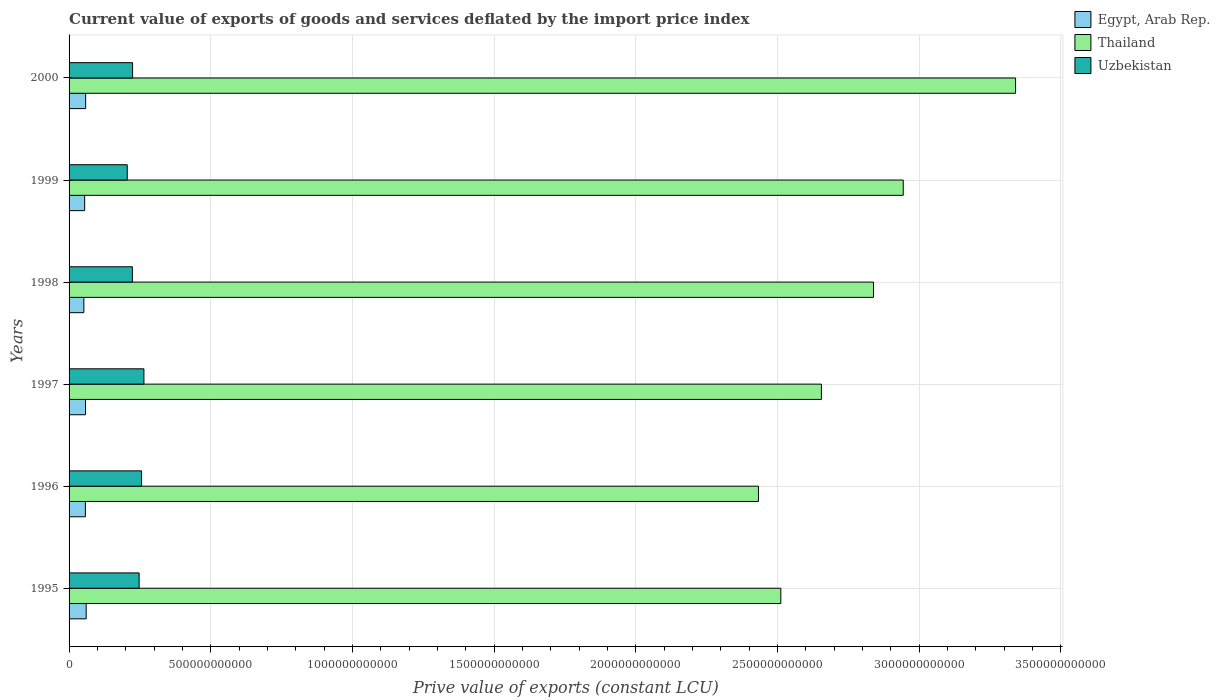How many different coloured bars are there?
Provide a short and direct response. 3. Are the number of bars per tick equal to the number of legend labels?
Keep it short and to the point. Yes. What is the prive value of exports in Uzbekistan in 2000?
Offer a terse response. 2.24e+11. Across all years, what is the maximum prive value of exports in Uzbekistan?
Give a very brief answer. 2.64e+11. Across all years, what is the minimum prive value of exports in Egypt, Arab Rep.?
Give a very brief answer. 5.22e+1. In which year was the prive value of exports in Egypt, Arab Rep. maximum?
Make the answer very short. 1995. In which year was the prive value of exports in Uzbekistan minimum?
Keep it short and to the point. 1999. What is the total prive value of exports in Uzbekistan in the graph?
Offer a very short reply. 1.42e+12. What is the difference between the prive value of exports in Thailand in 1998 and that in 1999?
Your response must be concise. -1.05e+11. What is the difference between the prive value of exports in Uzbekistan in 1996 and the prive value of exports in Thailand in 1997?
Give a very brief answer. -2.40e+12. What is the average prive value of exports in Egypt, Arab Rep. per year?
Ensure brevity in your answer.  5.70e+1. In the year 1999, what is the difference between the prive value of exports in Egypt, Arab Rep. and prive value of exports in Thailand?
Provide a succinct answer. -2.89e+12. What is the ratio of the prive value of exports in Thailand in 1997 to that in 1999?
Give a very brief answer. 0.9. Is the prive value of exports in Egypt, Arab Rep. in 1999 less than that in 2000?
Provide a succinct answer. Yes. What is the difference between the highest and the second highest prive value of exports in Thailand?
Ensure brevity in your answer.  3.96e+11. What is the difference between the highest and the lowest prive value of exports in Egypt, Arab Rep.?
Offer a very short reply. 8.20e+09. What does the 3rd bar from the top in 1999 represents?
Provide a succinct answer. Egypt, Arab Rep. What does the 1st bar from the bottom in 1998 represents?
Offer a terse response. Egypt, Arab Rep. Are all the bars in the graph horizontal?
Offer a terse response. Yes. How many years are there in the graph?
Offer a very short reply. 6. What is the difference between two consecutive major ticks on the X-axis?
Give a very brief answer. 5.00e+11. Are the values on the major ticks of X-axis written in scientific E-notation?
Keep it short and to the point. No. Does the graph contain any zero values?
Your answer should be very brief. No. Does the graph contain grids?
Your answer should be very brief. Yes. Where does the legend appear in the graph?
Your response must be concise. Top right. How many legend labels are there?
Provide a succinct answer. 3. How are the legend labels stacked?
Your response must be concise. Vertical. What is the title of the graph?
Give a very brief answer. Current value of exports of goods and services deflated by the import price index. Does "South Sudan" appear as one of the legend labels in the graph?
Provide a succinct answer. No. What is the label or title of the X-axis?
Your answer should be compact. Prive value of exports (constant LCU). What is the Prive value of exports (constant LCU) in Egypt, Arab Rep. in 1995?
Your answer should be very brief. 6.04e+1. What is the Prive value of exports (constant LCU) in Thailand in 1995?
Keep it short and to the point. 2.51e+12. What is the Prive value of exports (constant LCU) in Uzbekistan in 1995?
Offer a very short reply. 2.47e+11. What is the Prive value of exports (constant LCU) of Egypt, Arab Rep. in 1996?
Keep it short and to the point. 5.76e+1. What is the Prive value of exports (constant LCU) of Thailand in 1996?
Give a very brief answer. 2.43e+12. What is the Prive value of exports (constant LCU) of Uzbekistan in 1996?
Offer a terse response. 2.56e+11. What is the Prive value of exports (constant LCU) of Egypt, Arab Rep. in 1997?
Provide a short and direct response. 5.80e+1. What is the Prive value of exports (constant LCU) of Thailand in 1997?
Your response must be concise. 2.65e+12. What is the Prive value of exports (constant LCU) of Uzbekistan in 1997?
Your response must be concise. 2.64e+11. What is the Prive value of exports (constant LCU) of Egypt, Arab Rep. in 1998?
Your response must be concise. 5.22e+1. What is the Prive value of exports (constant LCU) in Thailand in 1998?
Ensure brevity in your answer.  2.84e+12. What is the Prive value of exports (constant LCU) of Uzbekistan in 1998?
Give a very brief answer. 2.23e+11. What is the Prive value of exports (constant LCU) of Egypt, Arab Rep. in 1999?
Your answer should be very brief. 5.50e+1. What is the Prive value of exports (constant LCU) in Thailand in 1999?
Your response must be concise. 2.94e+12. What is the Prive value of exports (constant LCU) in Uzbekistan in 1999?
Make the answer very short. 2.05e+11. What is the Prive value of exports (constant LCU) in Egypt, Arab Rep. in 2000?
Give a very brief answer. 5.85e+1. What is the Prive value of exports (constant LCU) in Thailand in 2000?
Provide a short and direct response. 3.34e+12. What is the Prive value of exports (constant LCU) in Uzbekistan in 2000?
Your answer should be very brief. 2.24e+11. Across all years, what is the maximum Prive value of exports (constant LCU) of Egypt, Arab Rep.?
Your answer should be very brief. 6.04e+1. Across all years, what is the maximum Prive value of exports (constant LCU) in Thailand?
Offer a very short reply. 3.34e+12. Across all years, what is the maximum Prive value of exports (constant LCU) of Uzbekistan?
Your answer should be compact. 2.64e+11. Across all years, what is the minimum Prive value of exports (constant LCU) of Egypt, Arab Rep.?
Make the answer very short. 5.22e+1. Across all years, what is the minimum Prive value of exports (constant LCU) in Thailand?
Keep it short and to the point. 2.43e+12. Across all years, what is the minimum Prive value of exports (constant LCU) in Uzbekistan?
Your answer should be very brief. 2.05e+11. What is the total Prive value of exports (constant LCU) in Egypt, Arab Rep. in the graph?
Make the answer very short. 3.42e+11. What is the total Prive value of exports (constant LCU) of Thailand in the graph?
Ensure brevity in your answer.  1.67e+13. What is the total Prive value of exports (constant LCU) of Uzbekistan in the graph?
Your answer should be very brief. 1.42e+12. What is the difference between the Prive value of exports (constant LCU) in Egypt, Arab Rep. in 1995 and that in 1996?
Ensure brevity in your answer.  2.79e+09. What is the difference between the Prive value of exports (constant LCU) in Thailand in 1995 and that in 1996?
Provide a succinct answer. 7.90e+1. What is the difference between the Prive value of exports (constant LCU) in Uzbekistan in 1995 and that in 1996?
Your answer should be compact. -8.68e+09. What is the difference between the Prive value of exports (constant LCU) of Egypt, Arab Rep. in 1995 and that in 1997?
Offer a terse response. 2.39e+09. What is the difference between the Prive value of exports (constant LCU) in Thailand in 1995 and that in 1997?
Ensure brevity in your answer.  -1.43e+11. What is the difference between the Prive value of exports (constant LCU) in Uzbekistan in 1995 and that in 1997?
Provide a succinct answer. -1.70e+1. What is the difference between the Prive value of exports (constant LCU) of Egypt, Arab Rep. in 1995 and that in 1998?
Offer a very short reply. 8.20e+09. What is the difference between the Prive value of exports (constant LCU) of Thailand in 1995 and that in 1998?
Provide a short and direct response. -3.27e+11. What is the difference between the Prive value of exports (constant LCU) of Uzbekistan in 1995 and that in 1998?
Offer a very short reply. 2.38e+1. What is the difference between the Prive value of exports (constant LCU) of Egypt, Arab Rep. in 1995 and that in 1999?
Offer a very short reply. 5.37e+09. What is the difference between the Prive value of exports (constant LCU) of Thailand in 1995 and that in 1999?
Offer a terse response. -4.32e+11. What is the difference between the Prive value of exports (constant LCU) in Uzbekistan in 1995 and that in 1999?
Ensure brevity in your answer.  4.19e+1. What is the difference between the Prive value of exports (constant LCU) of Egypt, Arab Rep. in 1995 and that in 2000?
Offer a very short reply. 1.95e+09. What is the difference between the Prive value of exports (constant LCU) in Thailand in 1995 and that in 2000?
Your answer should be very brief. -8.28e+11. What is the difference between the Prive value of exports (constant LCU) of Uzbekistan in 1995 and that in 2000?
Your answer should be very brief. 2.30e+1. What is the difference between the Prive value of exports (constant LCU) of Egypt, Arab Rep. in 1996 and that in 1997?
Keep it short and to the point. -3.99e+08. What is the difference between the Prive value of exports (constant LCU) in Thailand in 1996 and that in 1997?
Your answer should be very brief. -2.22e+11. What is the difference between the Prive value of exports (constant LCU) in Uzbekistan in 1996 and that in 1997?
Provide a succinct answer. -8.28e+09. What is the difference between the Prive value of exports (constant LCU) in Egypt, Arab Rep. in 1996 and that in 1998?
Provide a succinct answer. 5.41e+09. What is the difference between the Prive value of exports (constant LCU) in Thailand in 1996 and that in 1998?
Give a very brief answer. -4.06e+11. What is the difference between the Prive value of exports (constant LCU) of Uzbekistan in 1996 and that in 1998?
Your response must be concise. 3.25e+1. What is the difference between the Prive value of exports (constant LCU) in Egypt, Arab Rep. in 1996 and that in 1999?
Provide a succinct answer. 2.58e+09. What is the difference between the Prive value of exports (constant LCU) of Thailand in 1996 and that in 1999?
Your answer should be compact. -5.11e+11. What is the difference between the Prive value of exports (constant LCU) in Uzbekistan in 1996 and that in 1999?
Offer a very short reply. 5.06e+1. What is the difference between the Prive value of exports (constant LCU) of Egypt, Arab Rep. in 1996 and that in 2000?
Your answer should be compact. -8.45e+08. What is the difference between the Prive value of exports (constant LCU) in Thailand in 1996 and that in 2000?
Provide a short and direct response. -9.07e+11. What is the difference between the Prive value of exports (constant LCU) in Uzbekistan in 1996 and that in 2000?
Provide a succinct answer. 3.17e+1. What is the difference between the Prive value of exports (constant LCU) in Egypt, Arab Rep. in 1997 and that in 1998?
Make the answer very short. 5.81e+09. What is the difference between the Prive value of exports (constant LCU) in Thailand in 1997 and that in 1998?
Provide a succinct answer. -1.84e+11. What is the difference between the Prive value of exports (constant LCU) in Uzbekistan in 1997 and that in 1998?
Keep it short and to the point. 4.07e+1. What is the difference between the Prive value of exports (constant LCU) of Egypt, Arab Rep. in 1997 and that in 1999?
Make the answer very short. 2.98e+09. What is the difference between the Prive value of exports (constant LCU) of Thailand in 1997 and that in 1999?
Offer a very short reply. -2.89e+11. What is the difference between the Prive value of exports (constant LCU) in Uzbekistan in 1997 and that in 1999?
Offer a terse response. 5.88e+1. What is the difference between the Prive value of exports (constant LCU) of Egypt, Arab Rep. in 1997 and that in 2000?
Keep it short and to the point. -4.45e+08. What is the difference between the Prive value of exports (constant LCU) in Thailand in 1997 and that in 2000?
Give a very brief answer. -6.85e+11. What is the difference between the Prive value of exports (constant LCU) in Uzbekistan in 1997 and that in 2000?
Keep it short and to the point. 4.00e+1. What is the difference between the Prive value of exports (constant LCU) of Egypt, Arab Rep. in 1998 and that in 1999?
Ensure brevity in your answer.  -2.83e+09. What is the difference between the Prive value of exports (constant LCU) of Thailand in 1998 and that in 1999?
Your answer should be compact. -1.05e+11. What is the difference between the Prive value of exports (constant LCU) in Uzbekistan in 1998 and that in 1999?
Keep it short and to the point. 1.81e+1. What is the difference between the Prive value of exports (constant LCU) in Egypt, Arab Rep. in 1998 and that in 2000?
Give a very brief answer. -6.25e+09. What is the difference between the Prive value of exports (constant LCU) in Thailand in 1998 and that in 2000?
Ensure brevity in your answer.  -5.01e+11. What is the difference between the Prive value of exports (constant LCU) of Uzbekistan in 1998 and that in 2000?
Offer a very short reply. -7.55e+08. What is the difference between the Prive value of exports (constant LCU) of Egypt, Arab Rep. in 1999 and that in 2000?
Your answer should be compact. -3.42e+09. What is the difference between the Prive value of exports (constant LCU) of Thailand in 1999 and that in 2000?
Ensure brevity in your answer.  -3.96e+11. What is the difference between the Prive value of exports (constant LCU) of Uzbekistan in 1999 and that in 2000?
Provide a short and direct response. -1.88e+1. What is the difference between the Prive value of exports (constant LCU) in Egypt, Arab Rep. in 1995 and the Prive value of exports (constant LCU) in Thailand in 1996?
Make the answer very short. -2.37e+12. What is the difference between the Prive value of exports (constant LCU) in Egypt, Arab Rep. in 1995 and the Prive value of exports (constant LCU) in Uzbekistan in 1996?
Make the answer very short. -1.95e+11. What is the difference between the Prive value of exports (constant LCU) in Thailand in 1995 and the Prive value of exports (constant LCU) in Uzbekistan in 1996?
Provide a short and direct response. 2.26e+12. What is the difference between the Prive value of exports (constant LCU) of Egypt, Arab Rep. in 1995 and the Prive value of exports (constant LCU) of Thailand in 1997?
Ensure brevity in your answer.  -2.59e+12. What is the difference between the Prive value of exports (constant LCU) of Egypt, Arab Rep. in 1995 and the Prive value of exports (constant LCU) of Uzbekistan in 1997?
Offer a terse response. -2.04e+11. What is the difference between the Prive value of exports (constant LCU) of Thailand in 1995 and the Prive value of exports (constant LCU) of Uzbekistan in 1997?
Your answer should be very brief. 2.25e+12. What is the difference between the Prive value of exports (constant LCU) in Egypt, Arab Rep. in 1995 and the Prive value of exports (constant LCU) in Thailand in 1998?
Offer a very short reply. -2.78e+12. What is the difference between the Prive value of exports (constant LCU) in Egypt, Arab Rep. in 1995 and the Prive value of exports (constant LCU) in Uzbekistan in 1998?
Keep it short and to the point. -1.63e+11. What is the difference between the Prive value of exports (constant LCU) in Thailand in 1995 and the Prive value of exports (constant LCU) in Uzbekistan in 1998?
Ensure brevity in your answer.  2.29e+12. What is the difference between the Prive value of exports (constant LCU) in Egypt, Arab Rep. in 1995 and the Prive value of exports (constant LCU) in Thailand in 1999?
Offer a terse response. -2.88e+12. What is the difference between the Prive value of exports (constant LCU) in Egypt, Arab Rep. in 1995 and the Prive value of exports (constant LCU) in Uzbekistan in 1999?
Your answer should be compact. -1.45e+11. What is the difference between the Prive value of exports (constant LCU) of Thailand in 1995 and the Prive value of exports (constant LCU) of Uzbekistan in 1999?
Provide a succinct answer. 2.31e+12. What is the difference between the Prive value of exports (constant LCU) in Egypt, Arab Rep. in 1995 and the Prive value of exports (constant LCU) in Thailand in 2000?
Offer a very short reply. -3.28e+12. What is the difference between the Prive value of exports (constant LCU) of Egypt, Arab Rep. in 1995 and the Prive value of exports (constant LCU) of Uzbekistan in 2000?
Make the answer very short. -1.64e+11. What is the difference between the Prive value of exports (constant LCU) of Thailand in 1995 and the Prive value of exports (constant LCU) of Uzbekistan in 2000?
Offer a terse response. 2.29e+12. What is the difference between the Prive value of exports (constant LCU) of Egypt, Arab Rep. in 1996 and the Prive value of exports (constant LCU) of Thailand in 1997?
Offer a very short reply. -2.60e+12. What is the difference between the Prive value of exports (constant LCU) in Egypt, Arab Rep. in 1996 and the Prive value of exports (constant LCU) in Uzbekistan in 1997?
Your answer should be very brief. -2.07e+11. What is the difference between the Prive value of exports (constant LCU) of Thailand in 1996 and the Prive value of exports (constant LCU) of Uzbekistan in 1997?
Keep it short and to the point. 2.17e+12. What is the difference between the Prive value of exports (constant LCU) in Egypt, Arab Rep. in 1996 and the Prive value of exports (constant LCU) in Thailand in 1998?
Ensure brevity in your answer.  -2.78e+12. What is the difference between the Prive value of exports (constant LCU) in Egypt, Arab Rep. in 1996 and the Prive value of exports (constant LCU) in Uzbekistan in 1998?
Ensure brevity in your answer.  -1.66e+11. What is the difference between the Prive value of exports (constant LCU) in Thailand in 1996 and the Prive value of exports (constant LCU) in Uzbekistan in 1998?
Provide a short and direct response. 2.21e+12. What is the difference between the Prive value of exports (constant LCU) of Egypt, Arab Rep. in 1996 and the Prive value of exports (constant LCU) of Thailand in 1999?
Provide a succinct answer. -2.89e+12. What is the difference between the Prive value of exports (constant LCU) of Egypt, Arab Rep. in 1996 and the Prive value of exports (constant LCU) of Uzbekistan in 1999?
Offer a very short reply. -1.48e+11. What is the difference between the Prive value of exports (constant LCU) of Thailand in 1996 and the Prive value of exports (constant LCU) of Uzbekistan in 1999?
Keep it short and to the point. 2.23e+12. What is the difference between the Prive value of exports (constant LCU) in Egypt, Arab Rep. in 1996 and the Prive value of exports (constant LCU) in Thailand in 2000?
Your response must be concise. -3.28e+12. What is the difference between the Prive value of exports (constant LCU) of Egypt, Arab Rep. in 1996 and the Prive value of exports (constant LCU) of Uzbekistan in 2000?
Ensure brevity in your answer.  -1.67e+11. What is the difference between the Prive value of exports (constant LCU) in Thailand in 1996 and the Prive value of exports (constant LCU) in Uzbekistan in 2000?
Give a very brief answer. 2.21e+12. What is the difference between the Prive value of exports (constant LCU) in Egypt, Arab Rep. in 1997 and the Prive value of exports (constant LCU) in Thailand in 1998?
Your answer should be compact. -2.78e+12. What is the difference between the Prive value of exports (constant LCU) in Egypt, Arab Rep. in 1997 and the Prive value of exports (constant LCU) in Uzbekistan in 1998?
Give a very brief answer. -1.65e+11. What is the difference between the Prive value of exports (constant LCU) in Thailand in 1997 and the Prive value of exports (constant LCU) in Uzbekistan in 1998?
Keep it short and to the point. 2.43e+12. What is the difference between the Prive value of exports (constant LCU) in Egypt, Arab Rep. in 1997 and the Prive value of exports (constant LCU) in Thailand in 1999?
Your answer should be very brief. -2.89e+12. What is the difference between the Prive value of exports (constant LCU) in Egypt, Arab Rep. in 1997 and the Prive value of exports (constant LCU) in Uzbekistan in 1999?
Give a very brief answer. -1.47e+11. What is the difference between the Prive value of exports (constant LCU) of Thailand in 1997 and the Prive value of exports (constant LCU) of Uzbekistan in 1999?
Offer a terse response. 2.45e+12. What is the difference between the Prive value of exports (constant LCU) of Egypt, Arab Rep. in 1997 and the Prive value of exports (constant LCU) of Thailand in 2000?
Offer a very short reply. -3.28e+12. What is the difference between the Prive value of exports (constant LCU) of Egypt, Arab Rep. in 1997 and the Prive value of exports (constant LCU) of Uzbekistan in 2000?
Provide a succinct answer. -1.66e+11. What is the difference between the Prive value of exports (constant LCU) of Thailand in 1997 and the Prive value of exports (constant LCU) of Uzbekistan in 2000?
Your answer should be very brief. 2.43e+12. What is the difference between the Prive value of exports (constant LCU) in Egypt, Arab Rep. in 1998 and the Prive value of exports (constant LCU) in Thailand in 1999?
Provide a short and direct response. -2.89e+12. What is the difference between the Prive value of exports (constant LCU) of Egypt, Arab Rep. in 1998 and the Prive value of exports (constant LCU) of Uzbekistan in 1999?
Your answer should be very brief. -1.53e+11. What is the difference between the Prive value of exports (constant LCU) of Thailand in 1998 and the Prive value of exports (constant LCU) of Uzbekistan in 1999?
Offer a terse response. 2.63e+12. What is the difference between the Prive value of exports (constant LCU) in Egypt, Arab Rep. in 1998 and the Prive value of exports (constant LCU) in Thailand in 2000?
Offer a very short reply. -3.29e+12. What is the difference between the Prive value of exports (constant LCU) of Egypt, Arab Rep. in 1998 and the Prive value of exports (constant LCU) of Uzbekistan in 2000?
Ensure brevity in your answer.  -1.72e+11. What is the difference between the Prive value of exports (constant LCU) of Thailand in 1998 and the Prive value of exports (constant LCU) of Uzbekistan in 2000?
Offer a terse response. 2.61e+12. What is the difference between the Prive value of exports (constant LCU) in Egypt, Arab Rep. in 1999 and the Prive value of exports (constant LCU) in Thailand in 2000?
Your answer should be very brief. -3.28e+12. What is the difference between the Prive value of exports (constant LCU) in Egypt, Arab Rep. in 1999 and the Prive value of exports (constant LCU) in Uzbekistan in 2000?
Offer a terse response. -1.69e+11. What is the difference between the Prive value of exports (constant LCU) of Thailand in 1999 and the Prive value of exports (constant LCU) of Uzbekistan in 2000?
Your response must be concise. 2.72e+12. What is the average Prive value of exports (constant LCU) of Egypt, Arab Rep. per year?
Provide a short and direct response. 5.70e+1. What is the average Prive value of exports (constant LCU) in Thailand per year?
Keep it short and to the point. 2.79e+12. What is the average Prive value of exports (constant LCU) of Uzbekistan per year?
Provide a succinct answer. 2.37e+11. In the year 1995, what is the difference between the Prive value of exports (constant LCU) of Egypt, Arab Rep. and Prive value of exports (constant LCU) of Thailand?
Give a very brief answer. -2.45e+12. In the year 1995, what is the difference between the Prive value of exports (constant LCU) of Egypt, Arab Rep. and Prive value of exports (constant LCU) of Uzbekistan?
Make the answer very short. -1.87e+11. In the year 1995, what is the difference between the Prive value of exports (constant LCU) of Thailand and Prive value of exports (constant LCU) of Uzbekistan?
Make the answer very short. 2.26e+12. In the year 1996, what is the difference between the Prive value of exports (constant LCU) of Egypt, Arab Rep. and Prive value of exports (constant LCU) of Thailand?
Offer a terse response. -2.37e+12. In the year 1996, what is the difference between the Prive value of exports (constant LCU) in Egypt, Arab Rep. and Prive value of exports (constant LCU) in Uzbekistan?
Keep it short and to the point. -1.98e+11. In the year 1996, what is the difference between the Prive value of exports (constant LCU) of Thailand and Prive value of exports (constant LCU) of Uzbekistan?
Offer a terse response. 2.18e+12. In the year 1997, what is the difference between the Prive value of exports (constant LCU) of Egypt, Arab Rep. and Prive value of exports (constant LCU) of Thailand?
Ensure brevity in your answer.  -2.60e+12. In the year 1997, what is the difference between the Prive value of exports (constant LCU) in Egypt, Arab Rep. and Prive value of exports (constant LCU) in Uzbekistan?
Give a very brief answer. -2.06e+11. In the year 1997, what is the difference between the Prive value of exports (constant LCU) in Thailand and Prive value of exports (constant LCU) in Uzbekistan?
Ensure brevity in your answer.  2.39e+12. In the year 1998, what is the difference between the Prive value of exports (constant LCU) in Egypt, Arab Rep. and Prive value of exports (constant LCU) in Thailand?
Provide a succinct answer. -2.79e+12. In the year 1998, what is the difference between the Prive value of exports (constant LCU) of Egypt, Arab Rep. and Prive value of exports (constant LCU) of Uzbekistan?
Keep it short and to the point. -1.71e+11. In the year 1998, what is the difference between the Prive value of exports (constant LCU) of Thailand and Prive value of exports (constant LCU) of Uzbekistan?
Offer a terse response. 2.62e+12. In the year 1999, what is the difference between the Prive value of exports (constant LCU) in Egypt, Arab Rep. and Prive value of exports (constant LCU) in Thailand?
Make the answer very short. -2.89e+12. In the year 1999, what is the difference between the Prive value of exports (constant LCU) of Egypt, Arab Rep. and Prive value of exports (constant LCU) of Uzbekistan?
Your response must be concise. -1.50e+11. In the year 1999, what is the difference between the Prive value of exports (constant LCU) in Thailand and Prive value of exports (constant LCU) in Uzbekistan?
Give a very brief answer. 2.74e+12. In the year 2000, what is the difference between the Prive value of exports (constant LCU) in Egypt, Arab Rep. and Prive value of exports (constant LCU) in Thailand?
Ensure brevity in your answer.  -3.28e+12. In the year 2000, what is the difference between the Prive value of exports (constant LCU) of Egypt, Arab Rep. and Prive value of exports (constant LCU) of Uzbekistan?
Give a very brief answer. -1.66e+11. In the year 2000, what is the difference between the Prive value of exports (constant LCU) of Thailand and Prive value of exports (constant LCU) of Uzbekistan?
Provide a succinct answer. 3.12e+12. What is the ratio of the Prive value of exports (constant LCU) in Egypt, Arab Rep. in 1995 to that in 1996?
Your answer should be compact. 1.05. What is the ratio of the Prive value of exports (constant LCU) of Thailand in 1995 to that in 1996?
Offer a terse response. 1.03. What is the ratio of the Prive value of exports (constant LCU) in Uzbekistan in 1995 to that in 1996?
Give a very brief answer. 0.97. What is the ratio of the Prive value of exports (constant LCU) in Egypt, Arab Rep. in 1995 to that in 1997?
Ensure brevity in your answer.  1.04. What is the ratio of the Prive value of exports (constant LCU) in Thailand in 1995 to that in 1997?
Offer a very short reply. 0.95. What is the ratio of the Prive value of exports (constant LCU) in Uzbekistan in 1995 to that in 1997?
Offer a very short reply. 0.94. What is the ratio of the Prive value of exports (constant LCU) of Egypt, Arab Rep. in 1995 to that in 1998?
Make the answer very short. 1.16. What is the ratio of the Prive value of exports (constant LCU) in Thailand in 1995 to that in 1998?
Keep it short and to the point. 0.88. What is the ratio of the Prive value of exports (constant LCU) in Uzbekistan in 1995 to that in 1998?
Offer a very short reply. 1.11. What is the ratio of the Prive value of exports (constant LCU) in Egypt, Arab Rep. in 1995 to that in 1999?
Provide a short and direct response. 1.1. What is the ratio of the Prive value of exports (constant LCU) in Thailand in 1995 to that in 1999?
Keep it short and to the point. 0.85. What is the ratio of the Prive value of exports (constant LCU) in Uzbekistan in 1995 to that in 1999?
Your answer should be compact. 1.2. What is the ratio of the Prive value of exports (constant LCU) of Egypt, Arab Rep. in 1995 to that in 2000?
Make the answer very short. 1.03. What is the ratio of the Prive value of exports (constant LCU) of Thailand in 1995 to that in 2000?
Offer a very short reply. 0.75. What is the ratio of the Prive value of exports (constant LCU) in Uzbekistan in 1995 to that in 2000?
Your answer should be compact. 1.1. What is the ratio of the Prive value of exports (constant LCU) of Egypt, Arab Rep. in 1996 to that in 1997?
Provide a short and direct response. 0.99. What is the ratio of the Prive value of exports (constant LCU) of Thailand in 1996 to that in 1997?
Give a very brief answer. 0.92. What is the ratio of the Prive value of exports (constant LCU) in Uzbekistan in 1996 to that in 1997?
Your answer should be compact. 0.97. What is the ratio of the Prive value of exports (constant LCU) in Egypt, Arab Rep. in 1996 to that in 1998?
Your answer should be very brief. 1.1. What is the ratio of the Prive value of exports (constant LCU) in Thailand in 1996 to that in 1998?
Provide a succinct answer. 0.86. What is the ratio of the Prive value of exports (constant LCU) in Uzbekistan in 1996 to that in 1998?
Your response must be concise. 1.15. What is the ratio of the Prive value of exports (constant LCU) of Egypt, Arab Rep. in 1996 to that in 1999?
Your answer should be compact. 1.05. What is the ratio of the Prive value of exports (constant LCU) in Thailand in 1996 to that in 1999?
Your answer should be compact. 0.83. What is the ratio of the Prive value of exports (constant LCU) of Uzbekistan in 1996 to that in 1999?
Your answer should be compact. 1.25. What is the ratio of the Prive value of exports (constant LCU) in Egypt, Arab Rep. in 1996 to that in 2000?
Keep it short and to the point. 0.99. What is the ratio of the Prive value of exports (constant LCU) of Thailand in 1996 to that in 2000?
Give a very brief answer. 0.73. What is the ratio of the Prive value of exports (constant LCU) of Uzbekistan in 1996 to that in 2000?
Provide a short and direct response. 1.14. What is the ratio of the Prive value of exports (constant LCU) in Egypt, Arab Rep. in 1997 to that in 1998?
Provide a succinct answer. 1.11. What is the ratio of the Prive value of exports (constant LCU) of Thailand in 1997 to that in 1998?
Your answer should be very brief. 0.94. What is the ratio of the Prive value of exports (constant LCU) of Uzbekistan in 1997 to that in 1998?
Provide a succinct answer. 1.18. What is the ratio of the Prive value of exports (constant LCU) in Egypt, Arab Rep. in 1997 to that in 1999?
Your response must be concise. 1.05. What is the ratio of the Prive value of exports (constant LCU) in Thailand in 1997 to that in 1999?
Make the answer very short. 0.9. What is the ratio of the Prive value of exports (constant LCU) in Uzbekistan in 1997 to that in 1999?
Your answer should be very brief. 1.29. What is the ratio of the Prive value of exports (constant LCU) of Thailand in 1997 to that in 2000?
Provide a succinct answer. 0.79. What is the ratio of the Prive value of exports (constant LCU) of Uzbekistan in 1997 to that in 2000?
Offer a terse response. 1.18. What is the ratio of the Prive value of exports (constant LCU) in Egypt, Arab Rep. in 1998 to that in 1999?
Your answer should be very brief. 0.95. What is the ratio of the Prive value of exports (constant LCU) in Uzbekistan in 1998 to that in 1999?
Give a very brief answer. 1.09. What is the ratio of the Prive value of exports (constant LCU) in Egypt, Arab Rep. in 1998 to that in 2000?
Ensure brevity in your answer.  0.89. What is the ratio of the Prive value of exports (constant LCU) in Thailand in 1998 to that in 2000?
Offer a terse response. 0.85. What is the ratio of the Prive value of exports (constant LCU) in Uzbekistan in 1998 to that in 2000?
Your answer should be very brief. 1. What is the ratio of the Prive value of exports (constant LCU) of Egypt, Arab Rep. in 1999 to that in 2000?
Your answer should be compact. 0.94. What is the ratio of the Prive value of exports (constant LCU) of Thailand in 1999 to that in 2000?
Your answer should be very brief. 0.88. What is the ratio of the Prive value of exports (constant LCU) in Uzbekistan in 1999 to that in 2000?
Make the answer very short. 0.92. What is the difference between the highest and the second highest Prive value of exports (constant LCU) in Egypt, Arab Rep.?
Provide a succinct answer. 1.95e+09. What is the difference between the highest and the second highest Prive value of exports (constant LCU) of Thailand?
Provide a succinct answer. 3.96e+11. What is the difference between the highest and the second highest Prive value of exports (constant LCU) in Uzbekistan?
Your answer should be compact. 8.28e+09. What is the difference between the highest and the lowest Prive value of exports (constant LCU) of Egypt, Arab Rep.?
Make the answer very short. 8.20e+09. What is the difference between the highest and the lowest Prive value of exports (constant LCU) of Thailand?
Provide a short and direct response. 9.07e+11. What is the difference between the highest and the lowest Prive value of exports (constant LCU) of Uzbekistan?
Keep it short and to the point. 5.88e+1. 